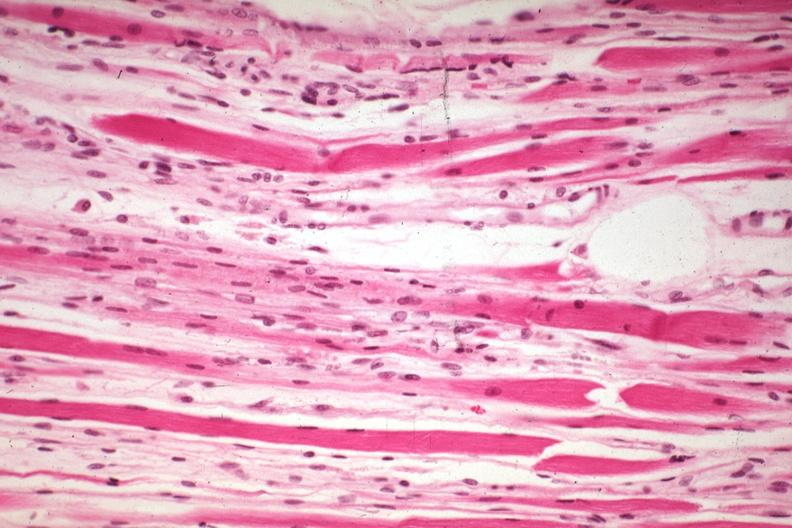what does this image show?
Answer the question using a single word or phrase. High excellent steroid induced atrophy 